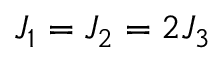Convert formula to latex. <formula><loc_0><loc_0><loc_500><loc_500>J _ { 1 } = J _ { 2 } = 2 J _ { 3 }</formula> 